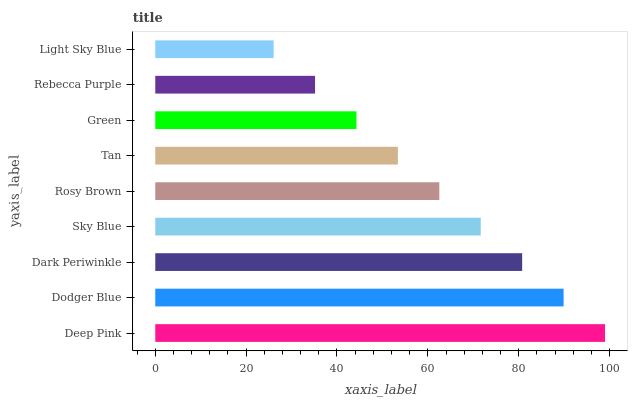Is Light Sky Blue the minimum?
Answer yes or no. Yes. Is Deep Pink the maximum?
Answer yes or no. Yes. Is Dodger Blue the minimum?
Answer yes or no. No. Is Dodger Blue the maximum?
Answer yes or no. No. Is Deep Pink greater than Dodger Blue?
Answer yes or no. Yes. Is Dodger Blue less than Deep Pink?
Answer yes or no. Yes. Is Dodger Blue greater than Deep Pink?
Answer yes or no. No. Is Deep Pink less than Dodger Blue?
Answer yes or no. No. Is Rosy Brown the high median?
Answer yes or no. Yes. Is Rosy Brown the low median?
Answer yes or no. Yes. Is Dark Periwinkle the high median?
Answer yes or no. No. Is Rebecca Purple the low median?
Answer yes or no. No. 